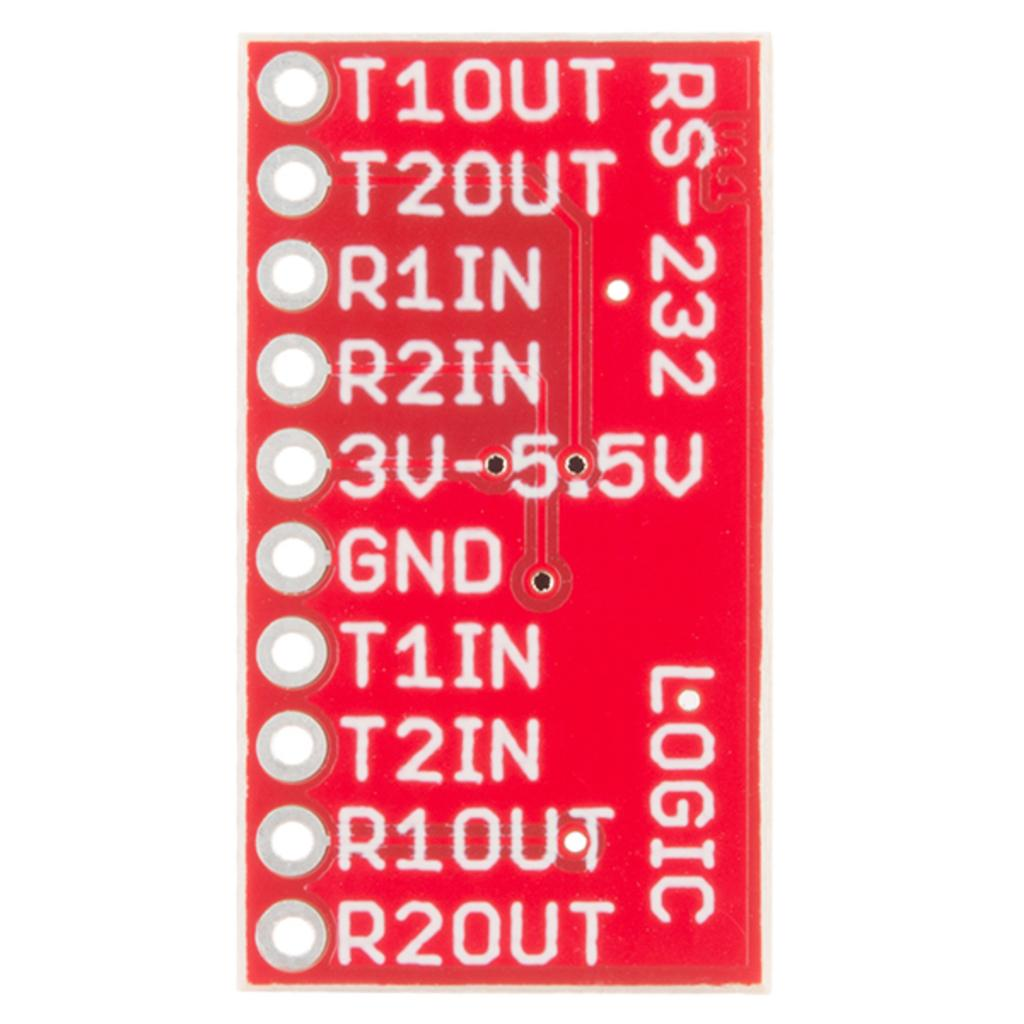<image>
Summarize the visual content of the image. A red computer chip has the word LOGIC on its lower right corner. 